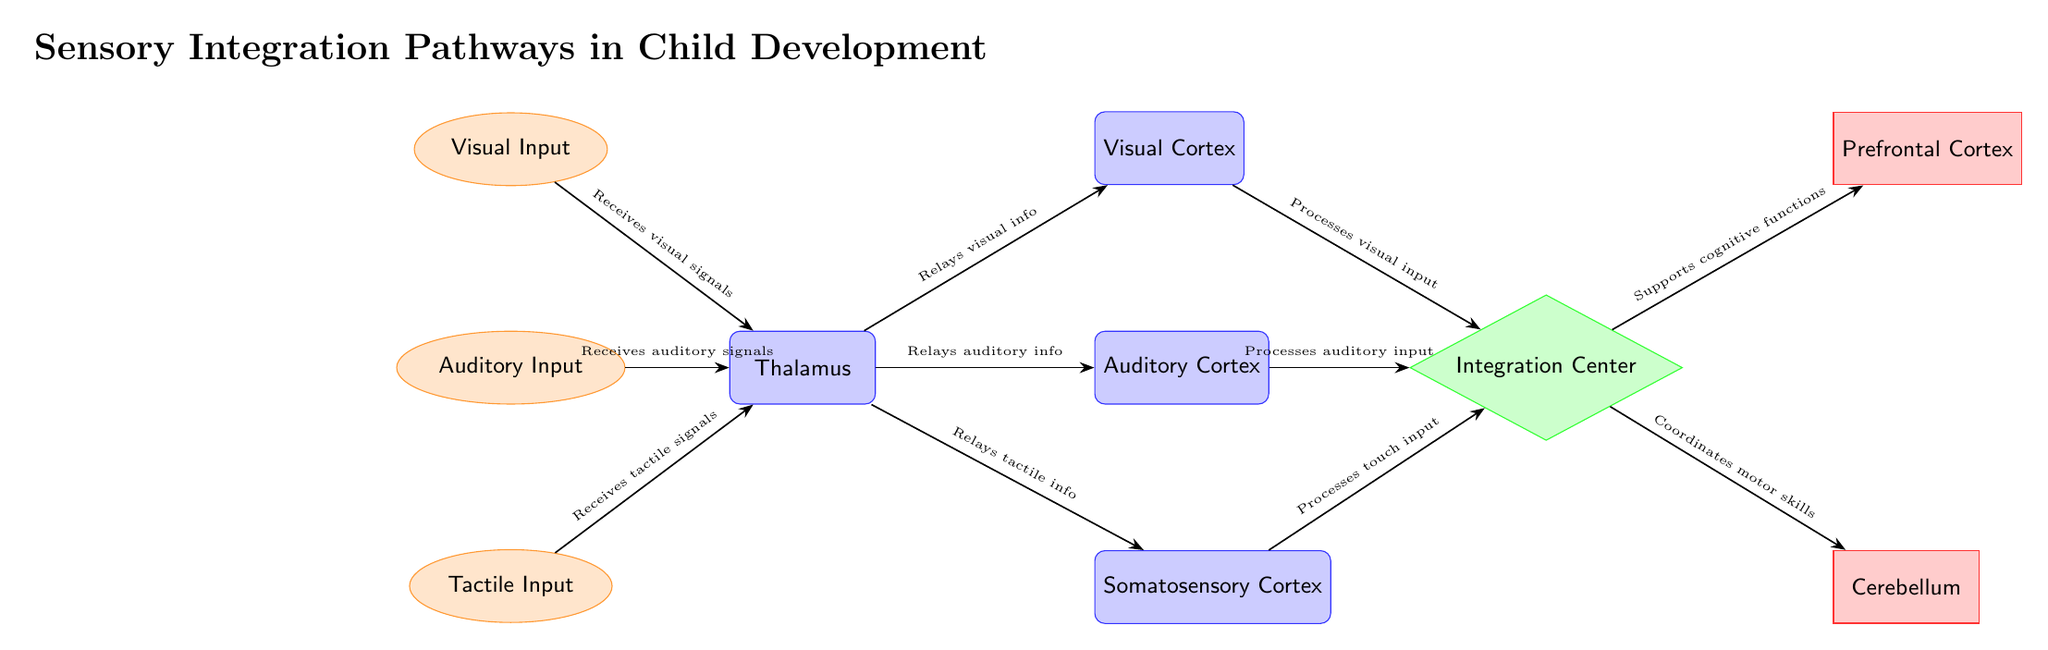What are the three types of sensory inputs illustrated in the diagram? The diagram shows three input nodes labeled as Visual Input, Auditory Input, and Tactile Input. These labels directly answer the question regarding the types of sensory inputs.
Answer: Visual Input, Auditory Input, Tactile Input How many cortical areas are involved in processing sensory information? The diagram features three cortical areas: Visual Cortex, Auditory Cortex, and Somatosensory Cortex. These areas are explicitly mentioned as part of the processing pathway.
Answer: Three What role does the Thalamus play in this diagram? The Thalamus is identified as a processing node that receives all three types of sensory inputs before relaying the information to their respective cortical areas, as indicated by the arrows.
Answer: Relay sensory information Which center integrates the processed sensory inputs? The Integration Center is depicted as the node that combines the processed inputs from the Visual Cortex, Auditory Cortex, and Somatosensory Cortex, consolidating the sensory data for further processing.
Answer: Integration Center Which output node is responsible for cognitive functions? According to the diagram, the Prefrontal Cortex is designated as the output node that supports cognitive functions, as shown by the arrow leading from the Integration Center.
Answer: Prefrontal Cortex What sensory information does the Visual Cortex specifically process? The diagram specifies that the Visual Cortex processes visual input, as indicated by the directional arrow from the Thalamus to the Visual Cortex with a corresponding label.
Answer: Visual input How does the Integration Center support motor skills? The diagram indicates that the Integration Center connects to the Cerebellum, which is responsible for coordinating motor skills, as shown by the arrow pointing towards the Cerebellum.
Answer: Coordinates motor skills What is the main function of the Integration Center in the diagram? The Integration Center processes and combines sensory inputs from various sources (Visual, Auditory, and Tactile) for cognitive and motor skill development, as inferred from the connections it has with different cortical areas and output nodes.
Answer: Combines sensory information 